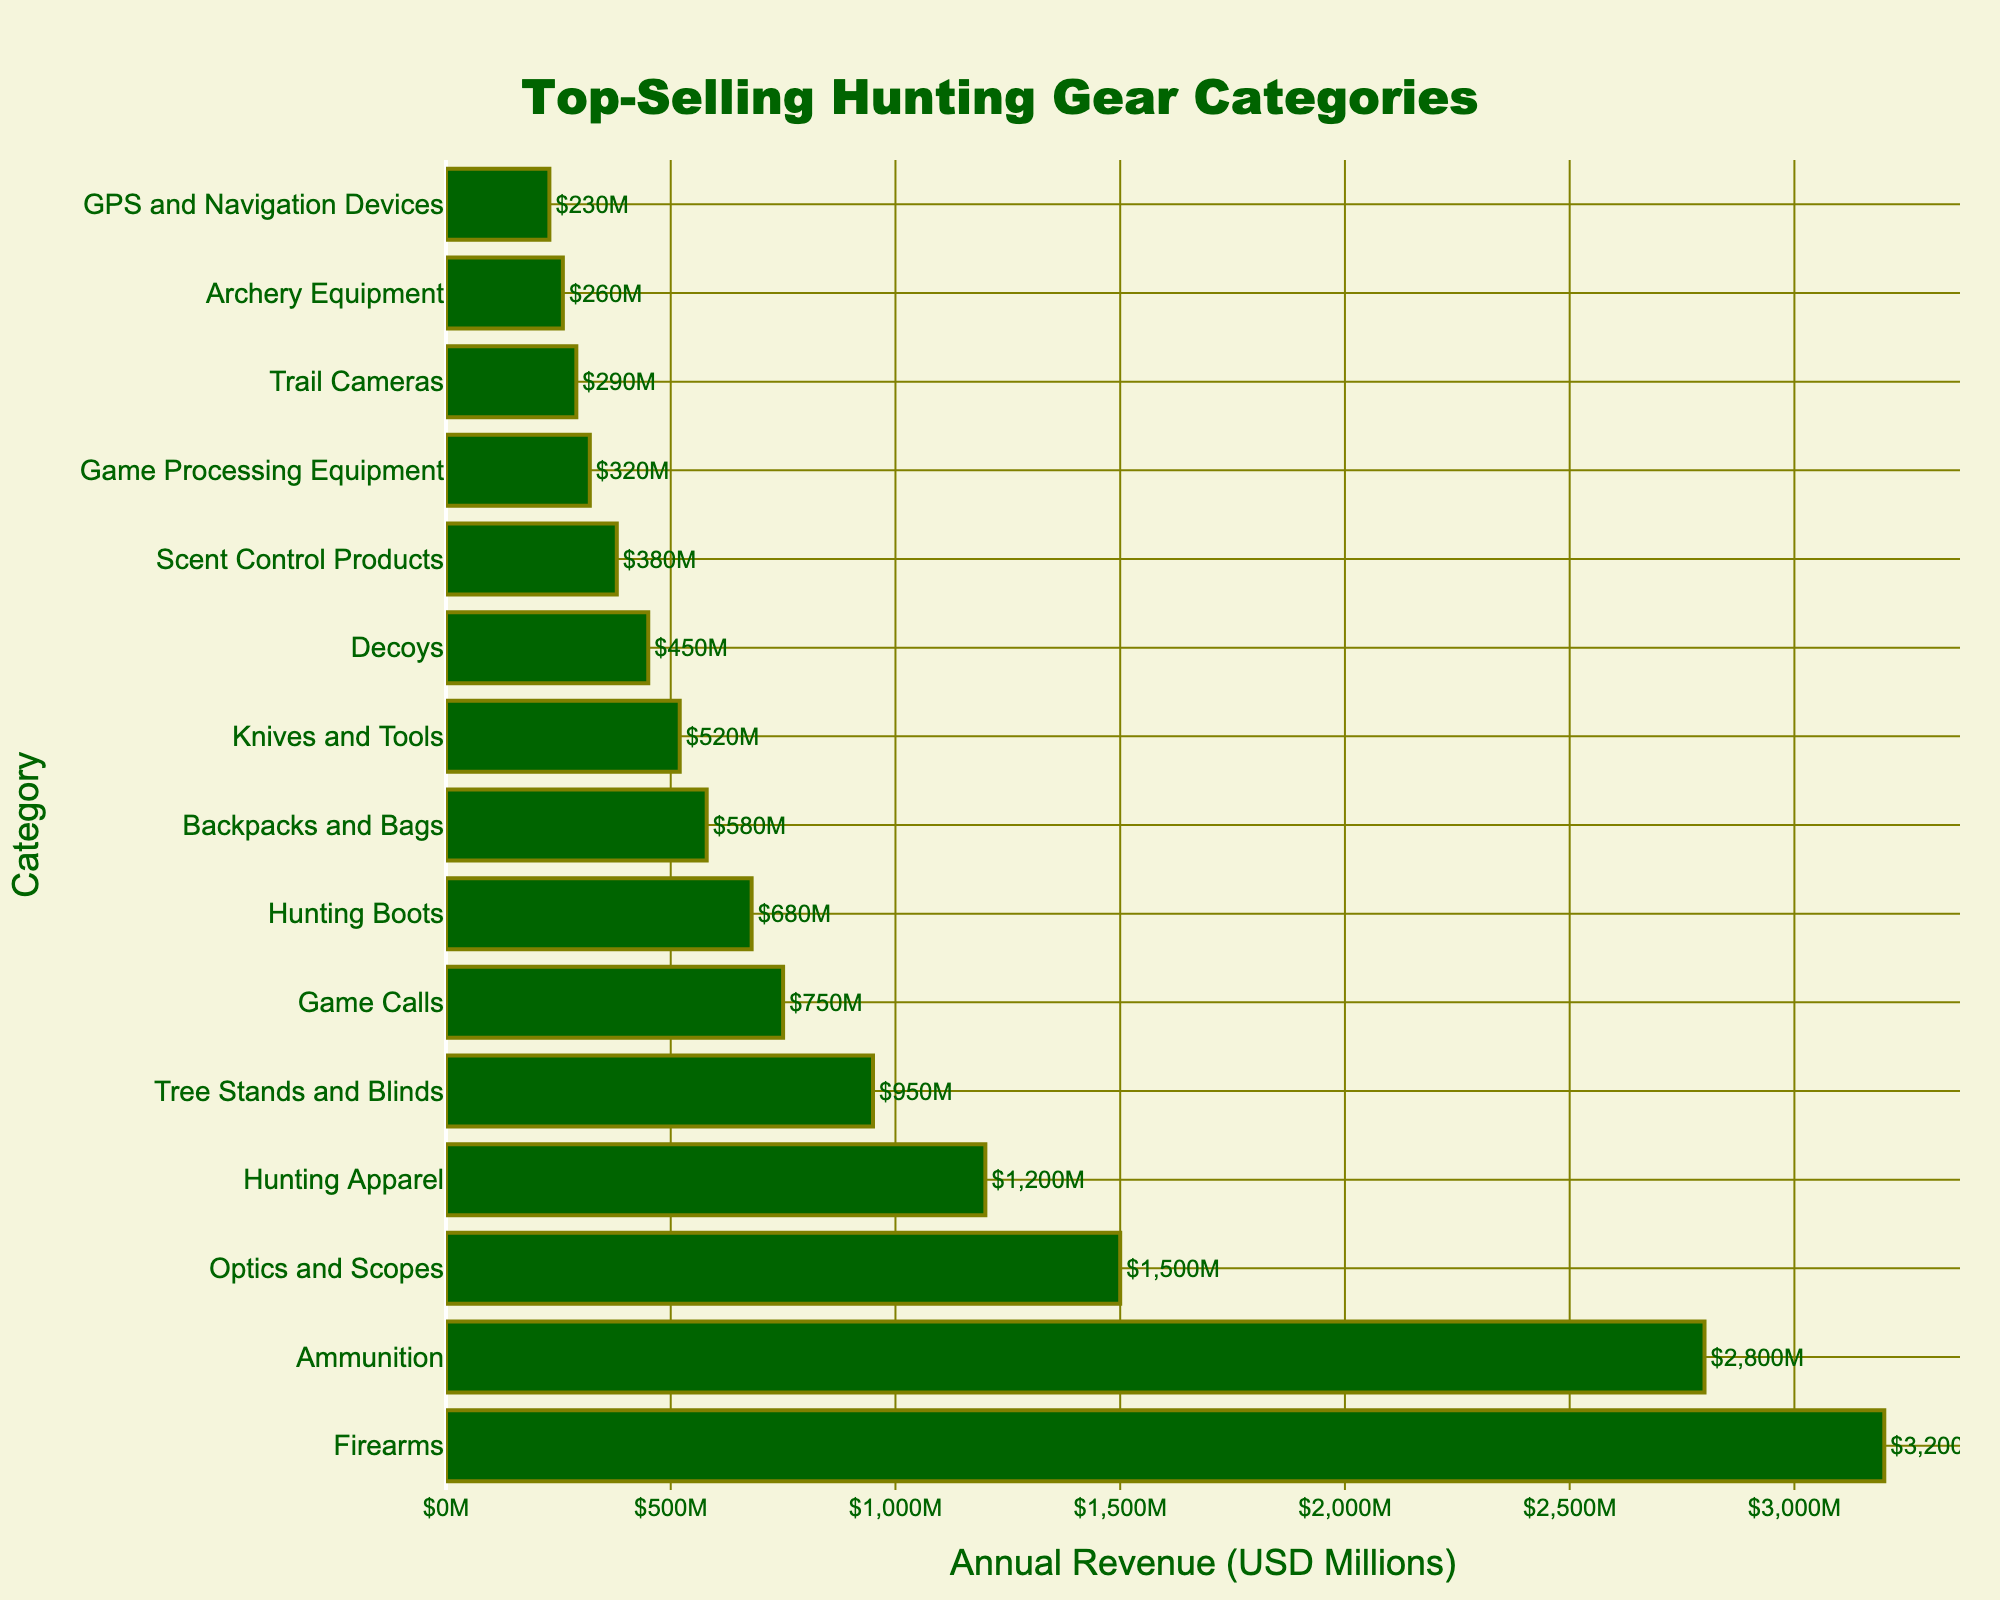Which hunting gear category has the highest annual revenue? By looking at the bar lengths, Firearms has the longest bar, indicating it has the highest annual revenue.
Answer: Firearms What is the total annual revenue of Optics and Scopes, Hunting Apparel, and Tree Stands and Blinds combined? The annual revenues are: Optics and Scopes: $1500M, Hunting Apparel: $1200M, Tree Stands and Blinds: $950M. Adding them together: 1500 + 1200 + 950 = $3650M
Answer: $3650M Which category has the least annual revenue, and what is its value? The shortest bar represents the category with the least revenue, which is GPS and Navigation Devices. Its revenue is $230M.
Answer: GPS and Navigation Devices, $230M How much more revenue does Firearms generate compared to Ammunition? Firearms revenue: $3200M, Ammunition revenue: $2800M. Difference: 3200 - 2800 = $400M
Answer: $400M Are there any categories with annual revenues less than $300M? By looking at the lengths of the bars, the categories with annual revenues less than $300M are Trail Cameras, Archery Equipment, and GPS and Navigation Devices.
Answer: Yes Which categories have annual revenues greater than $1000M? The categories with bars extending beyond $1000M are Firearms, Ammunition, Optics and Scopes, Hunting Apparel.
Answer: Firearms, Ammunition, Optics and Scopes, Hunting Apparel Compare the combined revenue of Game Calls and Knives and Tools to that of Hunting Boots. Which is greater? Game Calls: $750M, Knives and Tools: $520M, combined: 750 + 520 = $1270M. Hunting Boots: $680M. $1270M is greater than $680M.
Answer: Combined revenue of Game Calls and Knives and Tools is greater What is the difference between the annual revenues of the Optics and Scopes category and the Decoys category? Optics and Scopes revenue: $1500M, Decoys revenue: $450M. Difference: 1500 - 450 = $1050M
Answer: $1050M What is the average annual revenue of the top 4 hunting gear categories? The top 4 categories are: Firearms: $3200M, Ammunition: $2800M, Optics and Scopes: $1500M, Hunting Apparel: $1200M. Total: 3200 + 2800 + 1500 + 1200 = $8700M. Average: $8700M / 4 = $2175M
Answer: $2175M Which category, Game Processing Equipment or Scent Control Products, has a lower annual revenue, and by how much? Game Processing Equipment: $320M, Scent Control Products: $380M. Difference: 380 - 320 = $60M. Game Processing Equipment has a lower revenue.
Answer: Game Processing Equipment, by $60M 